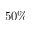<formula> <loc_0><loc_0><loc_500><loc_500>5 0 \%</formula> 